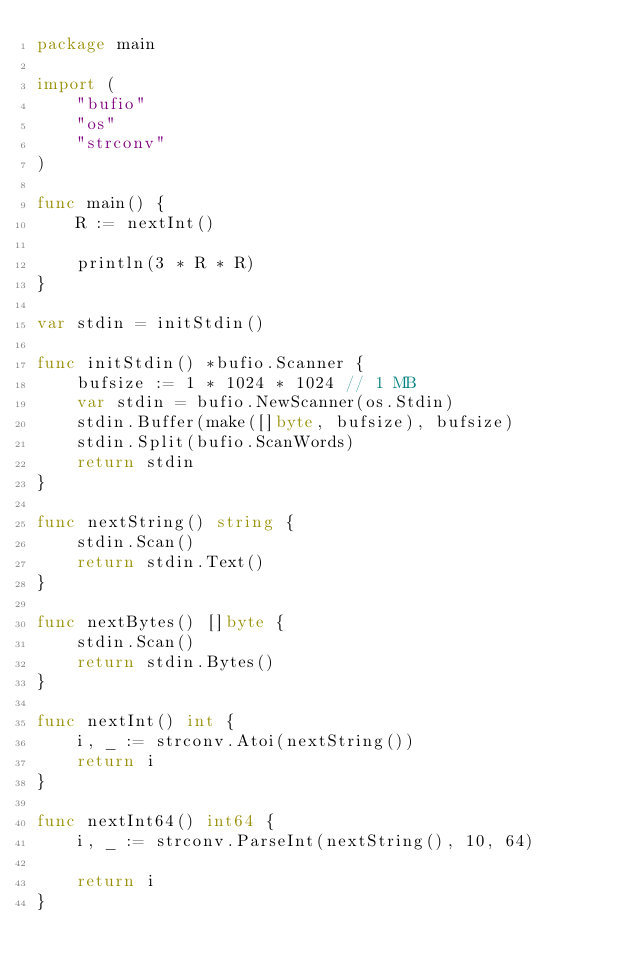<code> <loc_0><loc_0><loc_500><loc_500><_Go_>package main

import (
	"bufio"
	"os"
	"strconv"
)

func main() {
	R := nextInt()

	println(3 * R * R)
}

var stdin = initStdin()

func initStdin() *bufio.Scanner {
	bufsize := 1 * 1024 * 1024 // 1 MB
	var stdin = bufio.NewScanner(os.Stdin)
	stdin.Buffer(make([]byte, bufsize), bufsize)
	stdin.Split(bufio.ScanWords)
	return stdin
}

func nextString() string {
	stdin.Scan()
	return stdin.Text()
}

func nextBytes() []byte {
	stdin.Scan()
	return stdin.Bytes()
}

func nextInt() int {
	i, _ := strconv.Atoi(nextString())
	return i
}

func nextInt64() int64 {
	i, _ := strconv.ParseInt(nextString(), 10, 64)

	return i
}
</code> 